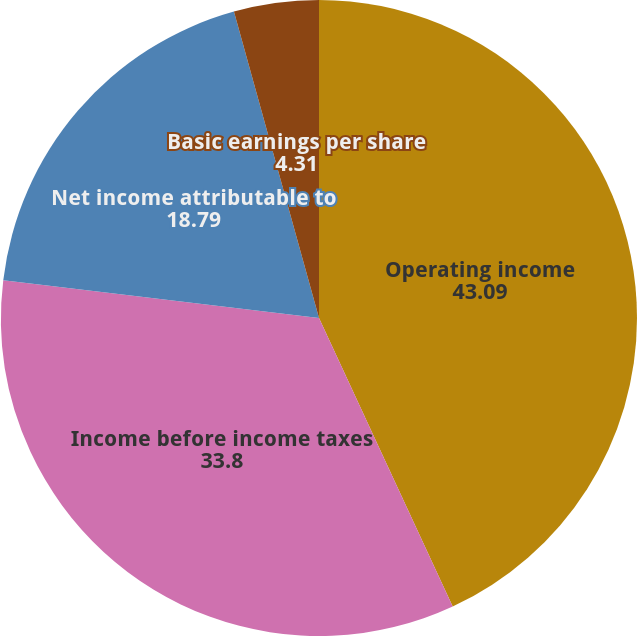<chart> <loc_0><loc_0><loc_500><loc_500><pie_chart><fcel>Operating income<fcel>Income before income taxes<fcel>Net income attributable to<fcel>Basic earnings per share<fcel>Diluted earnings per share<nl><fcel>43.09%<fcel>33.8%<fcel>18.79%<fcel>4.31%<fcel>0.0%<nl></chart> 